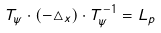Convert formula to latex. <formula><loc_0><loc_0><loc_500><loc_500>T _ { \psi } \cdot ( - \triangle _ { x } ) \cdot T _ { \psi } ^ { - 1 } = L _ { p }</formula> 